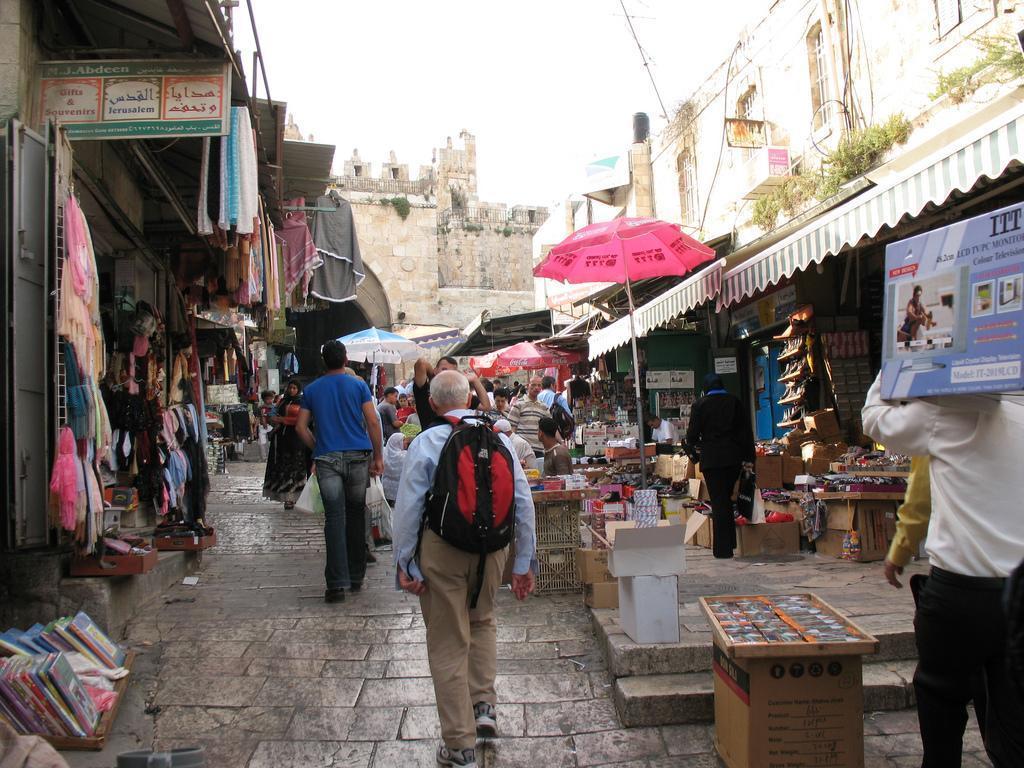How many umbrellas are pictured?
Give a very brief answer. 1. 